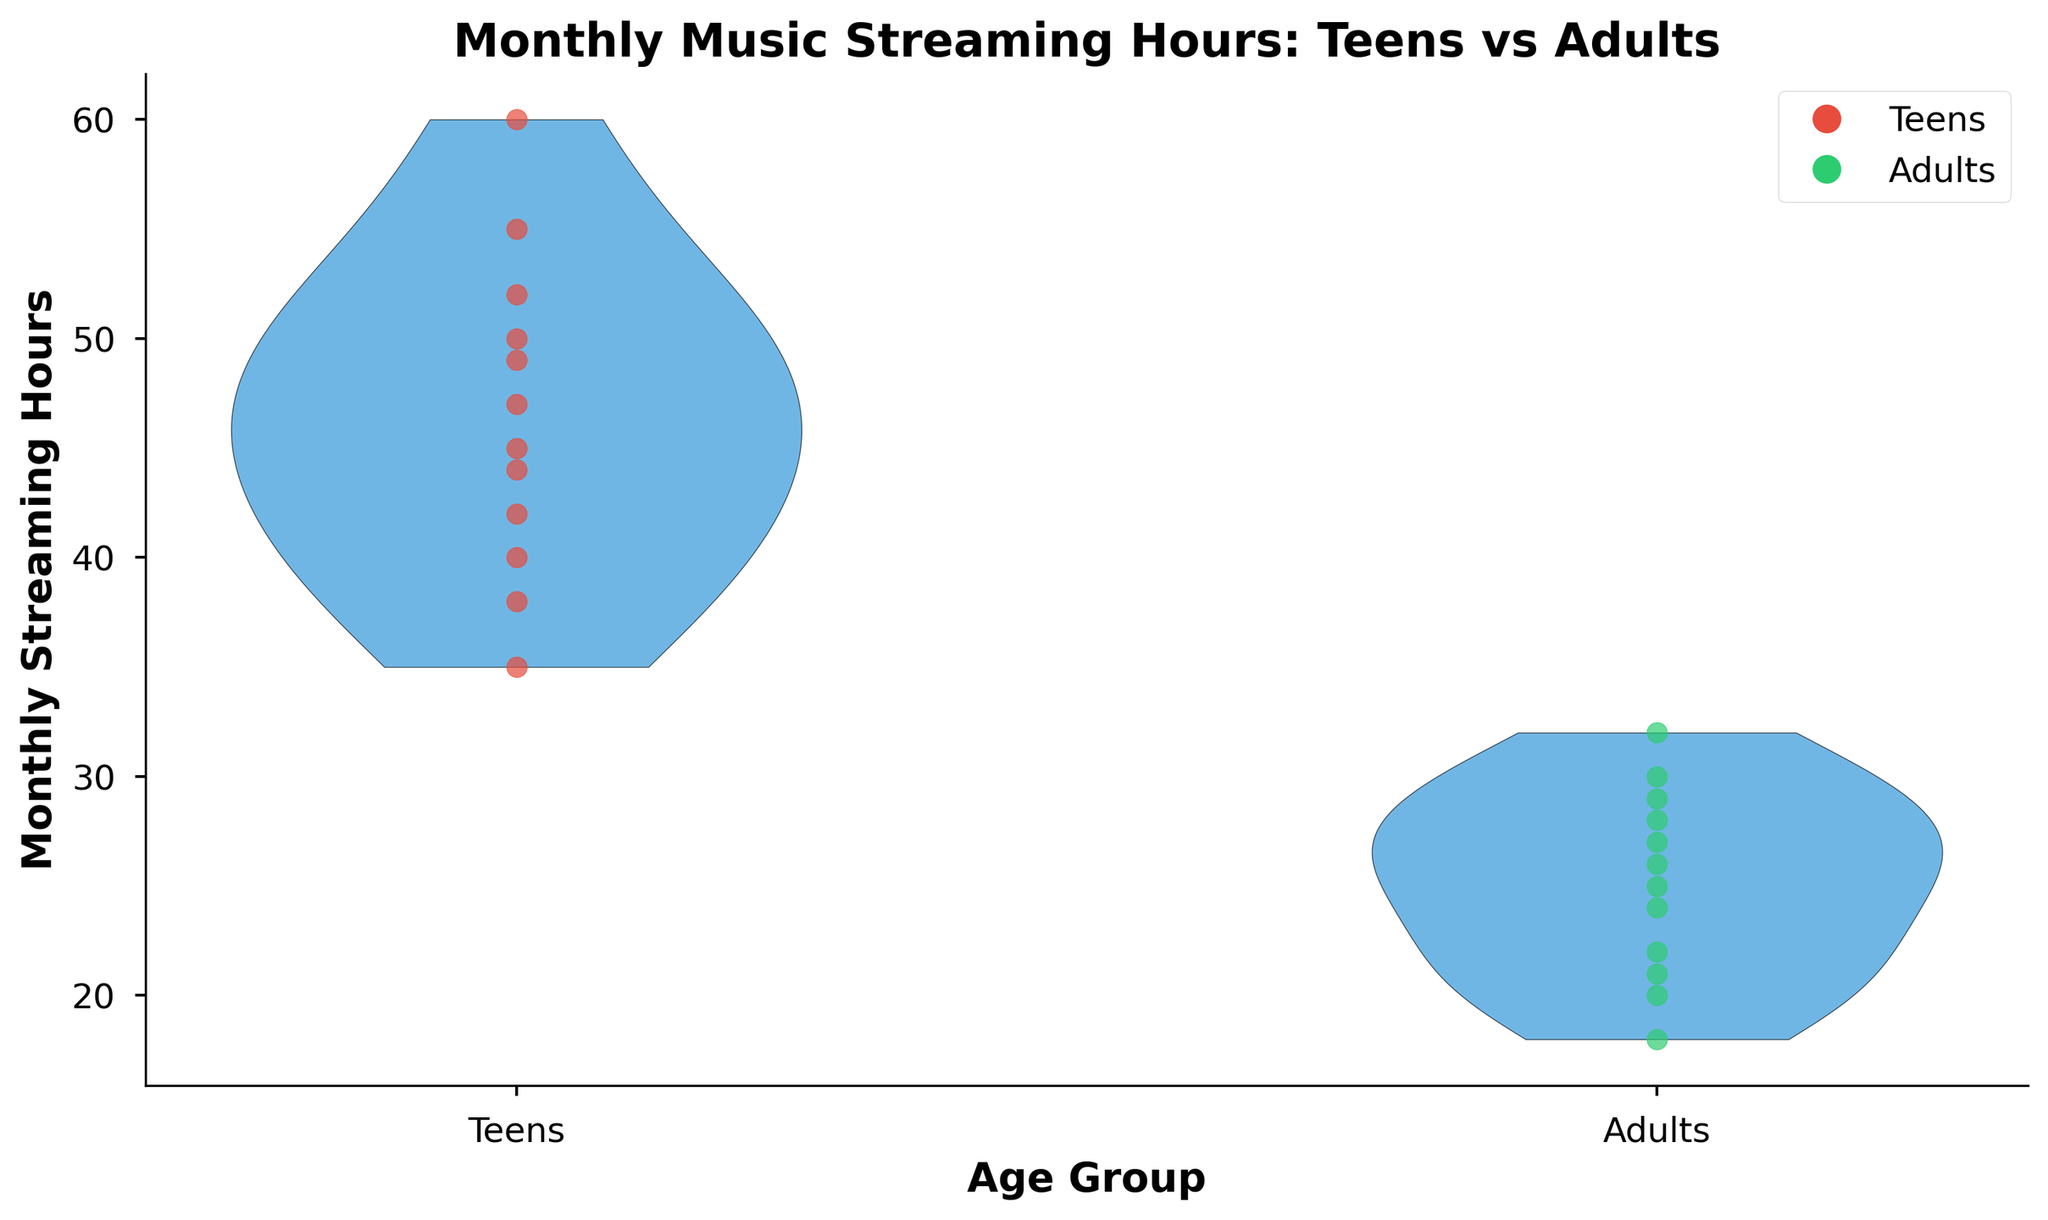What's the title of the chart? The title is displayed at the top of the chart which reads, "Monthly Music Streaming Hours: Teens vs Adults".
Answer: Monthly Music Streaming Hours: Teens vs Adults What are the two age groups compared in the chart? The x-axis labels show the two compared age groups: "Teens" and "Adults".
Answer: Teens and Adults What colors represent teens and adults respectively on the scatter plot? The legend indicates that red is used for teens and green is used for adults.
Answer: Red for teens, green for adults Which group, on average, seems to spend more hours streaming music? Observing the distribution of data points, the cluster representing teens is generally higher on the y-axis compared to the cluster representing adults.
Answer: Teens What is the maximum number of streaming hours observed for adults? From the distribution and the scattered data points, the highest point in the adults group on the y-axis reaches up to 32 hours.
Answer: 32 hours What's the difference in the maximum streaming hours between teens and adults? The maximum streaming hours for teens is 60 and for adults is 32. Subtracting these gives 60 - 32.
Answer: 28 hours How many samples are there for each age group? Count the number of data points (dots) in each group. Both teens and adults have 12 points each.
Answer: 12 samples for each group Which group shows a wider range of streaming hours? The spread of the data points for teens (from 35 to 60) is greater compared to the adults group (from 18 to 32).
Answer: Teens Do the majority of teens stream music more than 45 hours per month? Observing the scatter plot for teens, more than half of the data points (7 out of 12) are above 45 hours.
Answer: Yes What's the average streaming hours for teens? Summing all the streaming hours for teens and dividing by the number of samples, (40 + 35 + 45 + 50 + 38 + 42 + 55 + 60 + 47 + 52 + 44 + 49) / 12 gives an approximate average.
Answer: 46 hours 